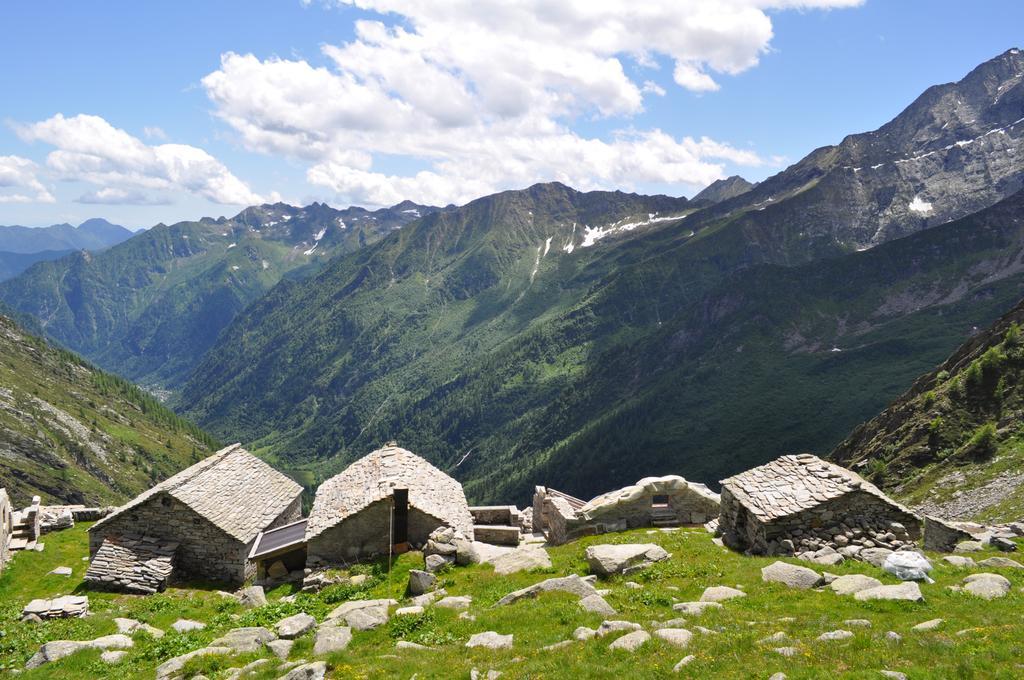In one or two sentences, can you explain what this image depicts? In this image I see the grass and I see 3 houses over here and I see the rocks. In the background I see the mountains and the clear sky. 